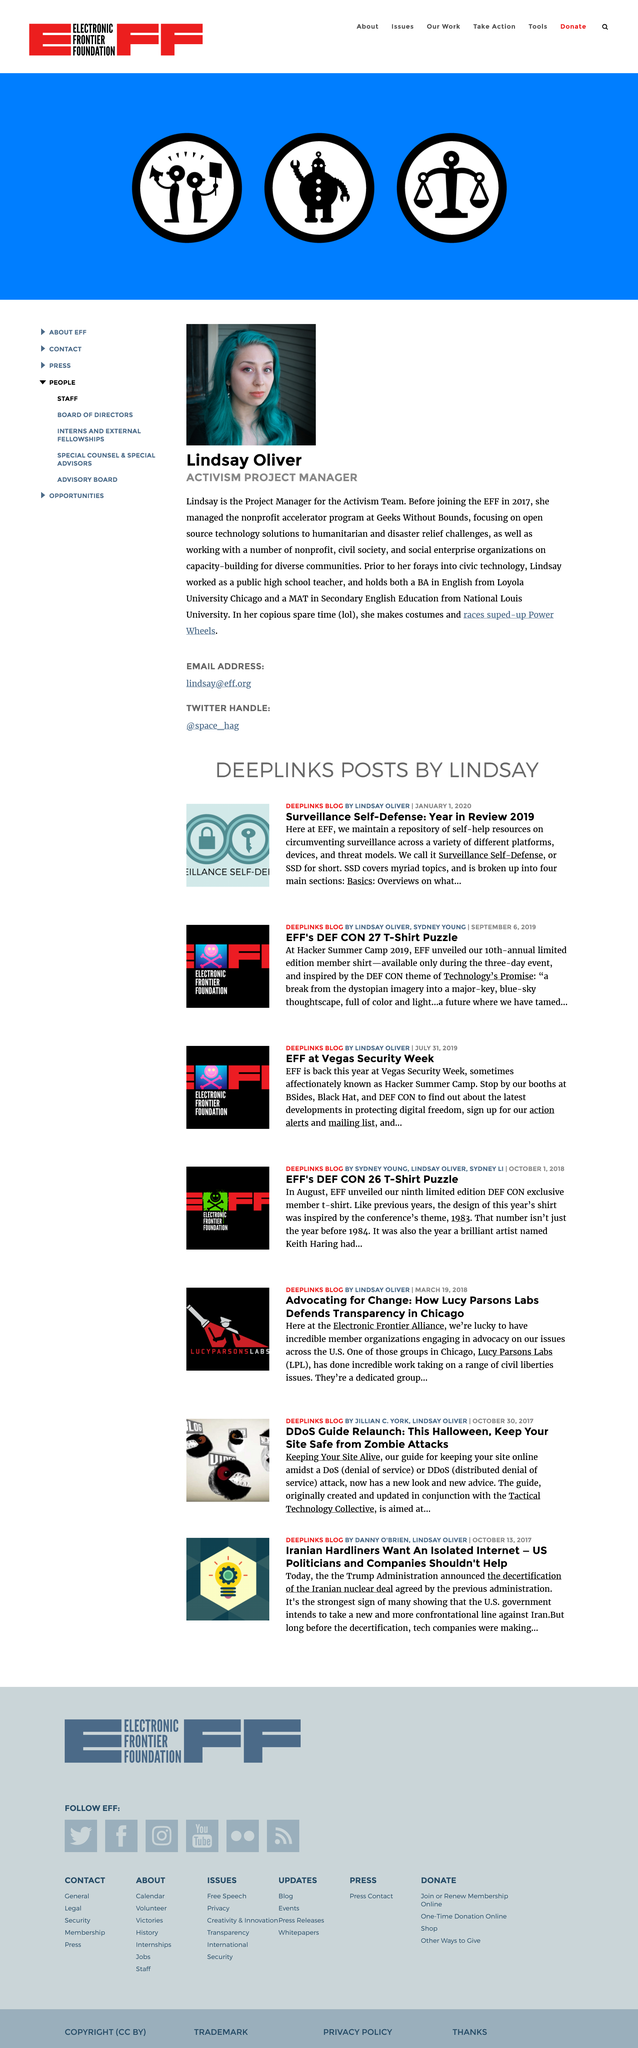Draw attention to some important aspects in this diagram. Lindsay Oliver is the activism project manager, holding a specific position within the organization. Lindsay Oliver obtained a Bachelor of Arts degree in English from Loyola University Chicago. Lindsay Oliver joined the EFF in 2017. 